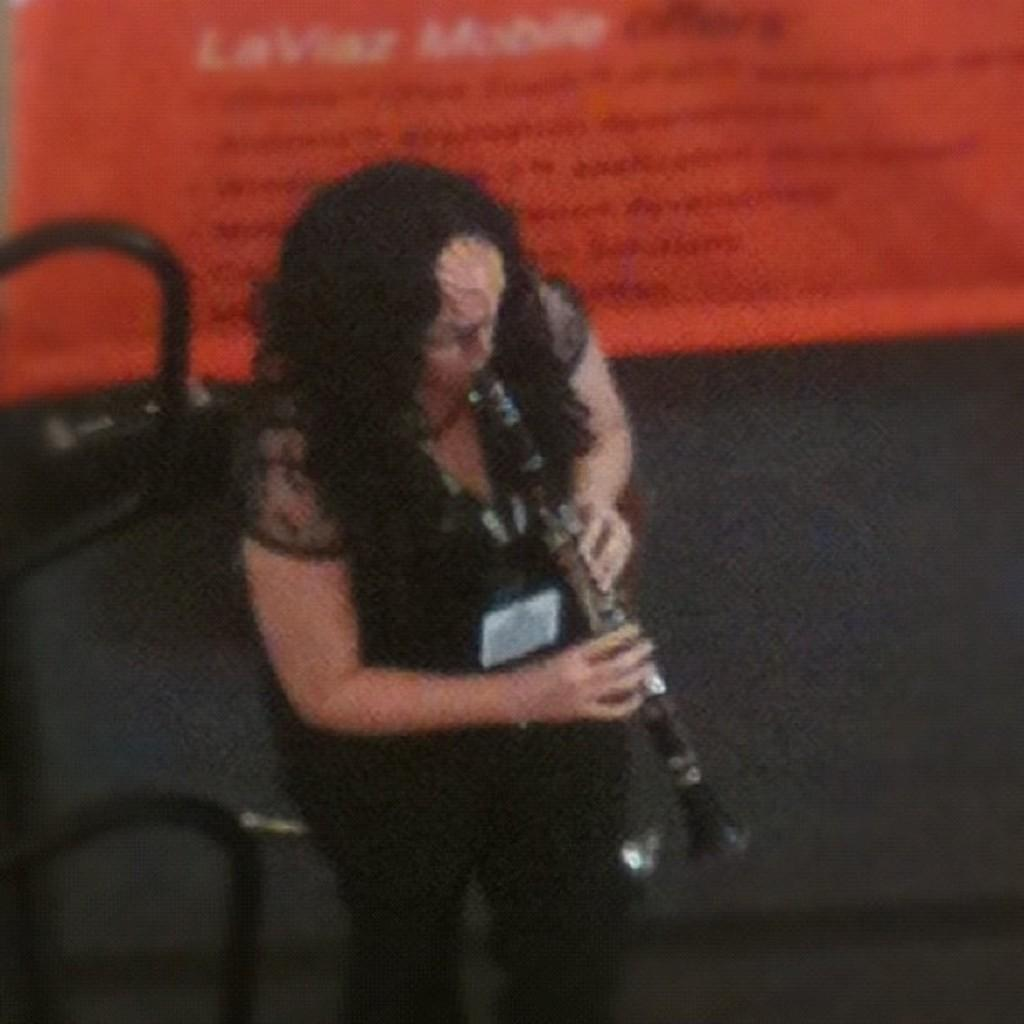Who is the main subject in the image? There is a woman in the image. What is the woman wearing? The woman is wearing a black dress. What is the woman doing in the image? The woman is standing and playing a trumpet. What else can be seen in the image besides the woman? There is a banner in the image, and it has writing on it. How many bikes are parked next to the woman in the image? There are no bikes present in the image. What type of map is the woman holding while playing the trumpet? The woman is not holding a map in the image; she is playing a trumpet and standing near a banner. 